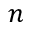<formula> <loc_0><loc_0><loc_500><loc_500>n</formula> 